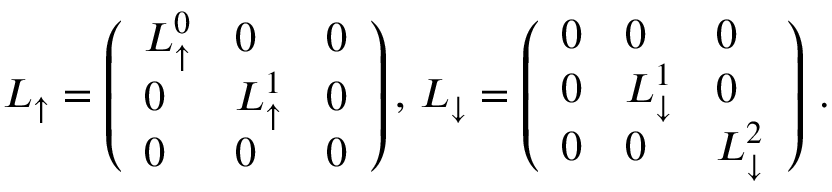<formula> <loc_0><loc_0><loc_500><loc_500>\begin{array} { r } { L _ { \uparrow } = \left ( \begin{array} { l l l } { L _ { \uparrow } ^ { 0 } } & { 0 } & { 0 } \\ { 0 } & { L _ { \uparrow } ^ { 1 } } & { 0 } \\ { 0 } & { 0 } & { 0 } \end{array} \right ) , \, L _ { \downarrow } = \left ( \begin{array} { l l l } { 0 } & { 0 } & { 0 } \\ { 0 } & { L _ { \downarrow } ^ { 1 } } & { 0 } \\ { 0 } & { 0 } & { L _ { \downarrow } ^ { 2 } } \end{array} \right ) \, . } \end{array}</formula> 